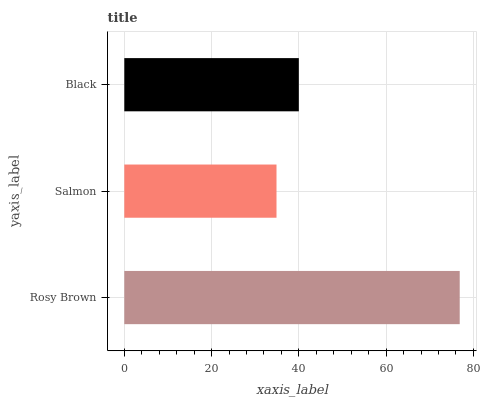Is Salmon the minimum?
Answer yes or no. Yes. Is Rosy Brown the maximum?
Answer yes or no. Yes. Is Black the minimum?
Answer yes or no. No. Is Black the maximum?
Answer yes or no. No. Is Black greater than Salmon?
Answer yes or no. Yes. Is Salmon less than Black?
Answer yes or no. Yes. Is Salmon greater than Black?
Answer yes or no. No. Is Black less than Salmon?
Answer yes or no. No. Is Black the high median?
Answer yes or no. Yes. Is Black the low median?
Answer yes or no. Yes. Is Salmon the high median?
Answer yes or no. No. Is Rosy Brown the low median?
Answer yes or no. No. 